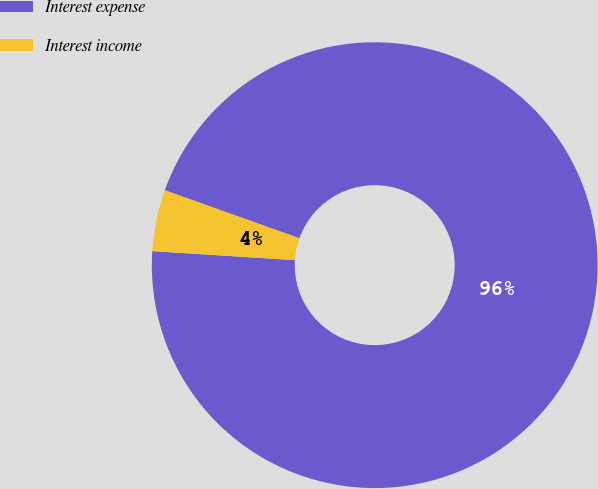Convert chart. <chart><loc_0><loc_0><loc_500><loc_500><pie_chart><fcel>Interest expense<fcel>Interest income<nl><fcel>95.55%<fcel>4.45%<nl></chart> 